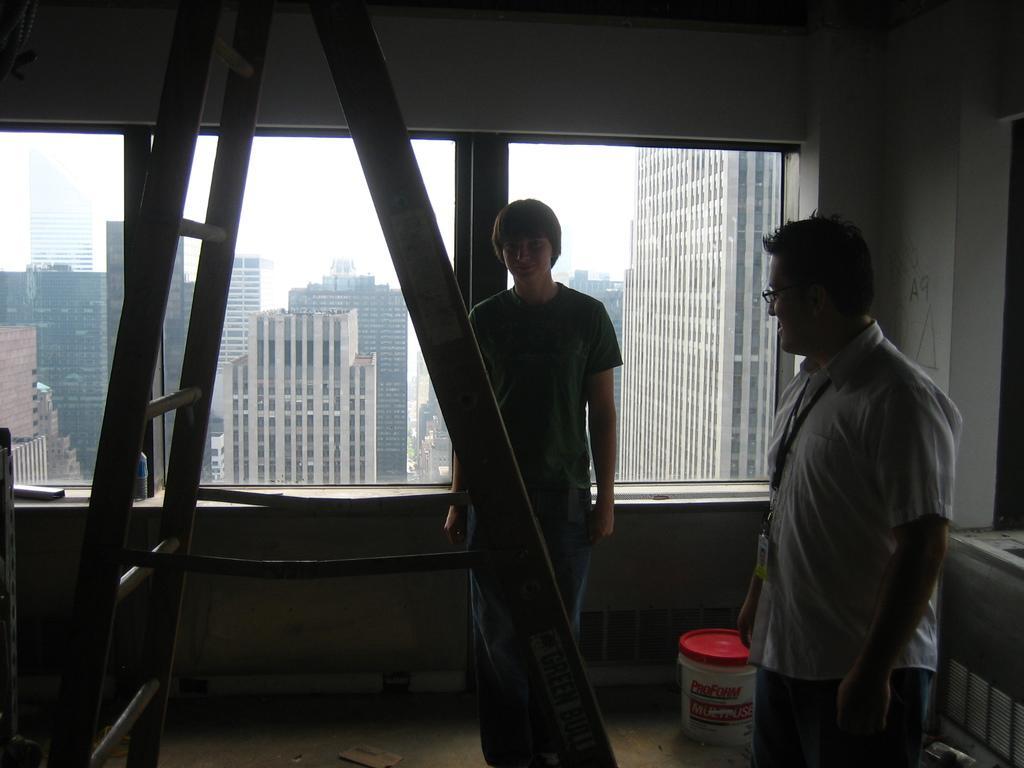Describe this image in one or two sentences. There are two persons standing as we can see on the right side of this image. There is a ladder at the bottom of this image. There is a glass window in the middle of this image. We can see there are some buildings through this glass. 